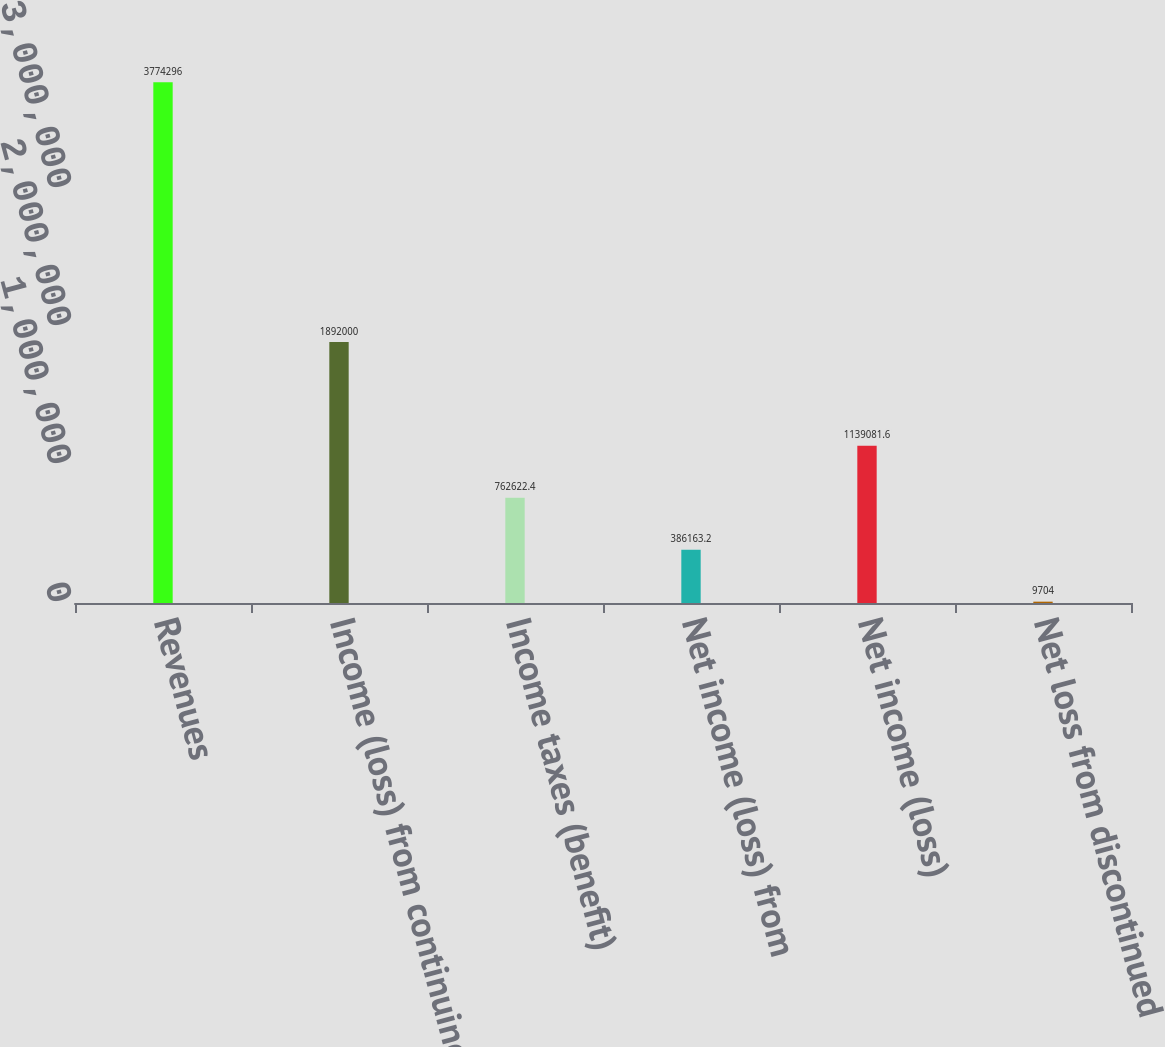Convert chart to OTSL. <chart><loc_0><loc_0><loc_500><loc_500><bar_chart><fcel>Revenues<fcel>Income (loss) from continuing<fcel>Income taxes (benefit)<fcel>Net income (loss) from<fcel>Net income (loss)<fcel>Net loss from discontinued<nl><fcel>3.7743e+06<fcel>1.892e+06<fcel>762622<fcel>386163<fcel>1.13908e+06<fcel>9704<nl></chart> 